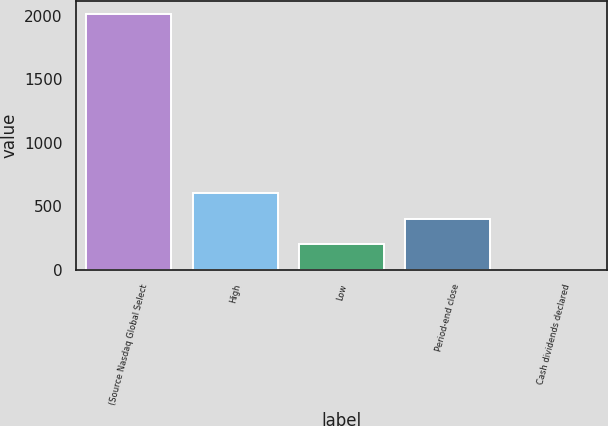Convert chart. <chart><loc_0><loc_0><loc_500><loc_500><bar_chart><fcel>(Source Nasdaq Global Select<fcel>High<fcel>Low<fcel>Period-end close<fcel>Cash dividends declared<nl><fcel>2012<fcel>603.88<fcel>201.56<fcel>402.72<fcel>0.4<nl></chart> 